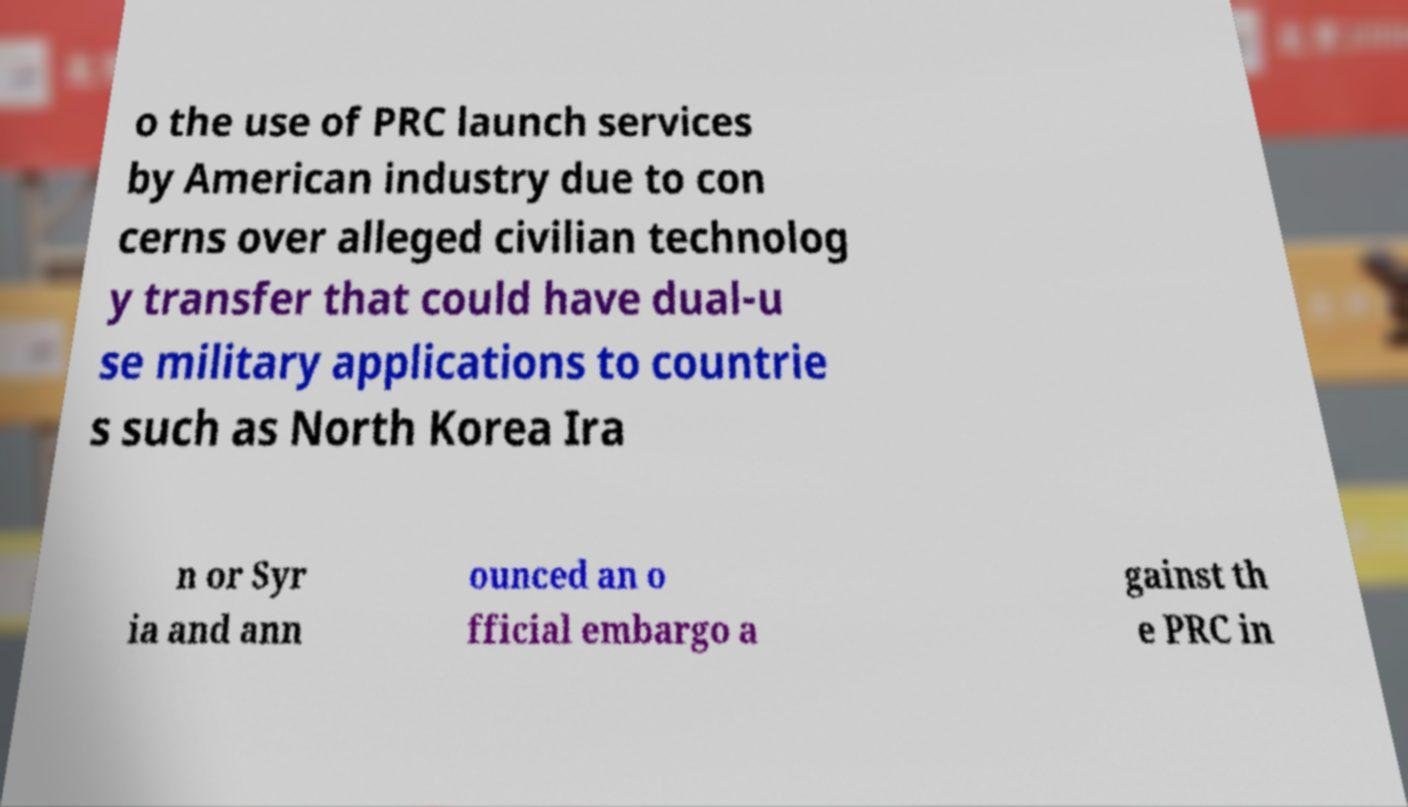For documentation purposes, I need the text within this image transcribed. Could you provide that? o the use of PRC launch services by American industry due to con cerns over alleged civilian technolog y transfer that could have dual-u se military applications to countrie s such as North Korea Ira n or Syr ia and ann ounced an o fficial embargo a gainst th e PRC in 